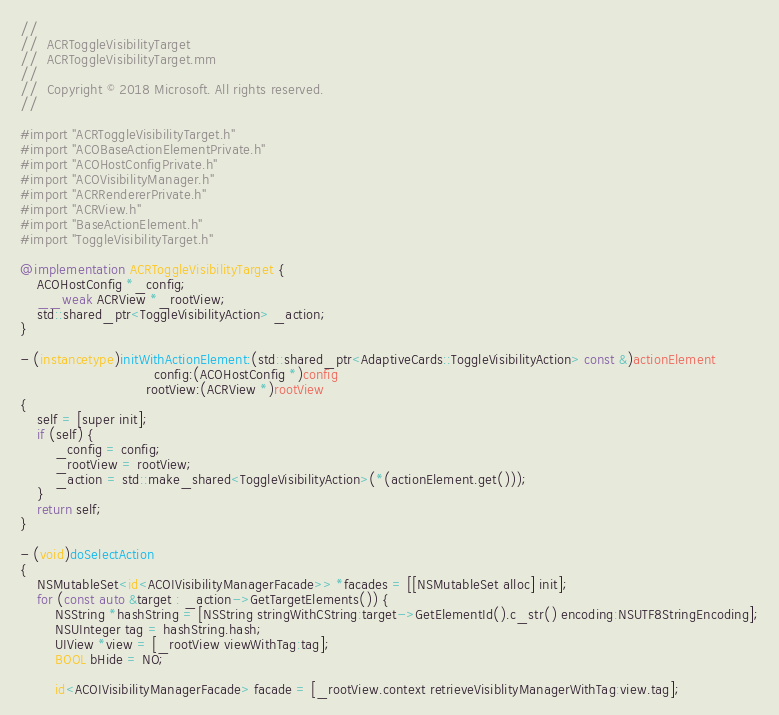Convert code to text. <code><loc_0><loc_0><loc_500><loc_500><_ObjectiveC_>//
//  ACRToggleVisibilityTarget
//  ACRToggleVisibilityTarget.mm
//
//  Copyright © 2018 Microsoft. All rights reserved.
//

#import "ACRToggleVisibilityTarget.h"
#import "ACOBaseActionElementPrivate.h"
#import "ACOHostConfigPrivate.h"
#import "ACOVisibilityManager.h"
#import "ACRRendererPrivate.h"
#import "ACRView.h"
#import "BaseActionElement.h"
#import "ToggleVisibilityTarget.h"

@implementation ACRToggleVisibilityTarget {
    ACOHostConfig *_config;
    __weak ACRView *_rootView;
    std::shared_ptr<ToggleVisibilityAction> _action;
}

- (instancetype)initWithActionElement:(std::shared_ptr<AdaptiveCards::ToggleVisibilityAction> const &)actionElement
                               config:(ACOHostConfig *)config
                             rootView:(ACRView *)rootView
{
    self = [super init];
    if (self) {
        _config = config;
        _rootView = rootView;
        _action = std::make_shared<ToggleVisibilityAction>(*(actionElement.get()));
    }
    return self;
}

- (void)doSelectAction
{
    NSMutableSet<id<ACOIVisibilityManagerFacade>> *facades = [[NSMutableSet alloc] init];
    for (const auto &target : _action->GetTargetElements()) {
        NSString *hashString = [NSString stringWithCString:target->GetElementId().c_str() encoding:NSUTF8StringEncoding];
        NSUInteger tag = hashString.hash;
        UIView *view = [_rootView viewWithTag:tag];
        BOOL bHide = NO;

        id<ACOIVisibilityManagerFacade> facade = [_rootView.context retrieveVisiblityManagerWithTag:view.tag];</code> 